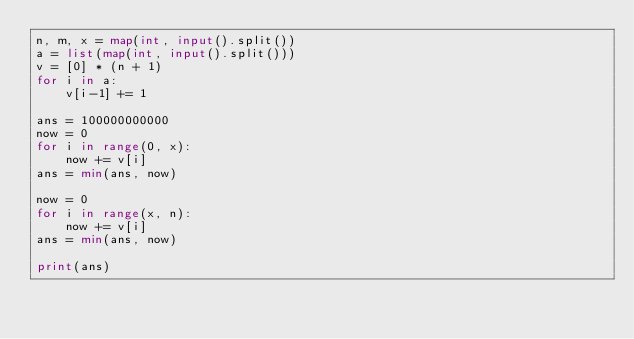<code> <loc_0><loc_0><loc_500><loc_500><_Python_>n, m, x = map(int, input().split())
a = list(map(int, input().split()))
v = [0] * (n + 1)
for i in a:
    v[i-1] += 1

ans = 100000000000
now = 0
for i in range(0, x):
    now += v[i]
ans = min(ans, now)

now = 0
for i in range(x, n):
    now += v[i]
ans = min(ans, now)

print(ans)
</code> 